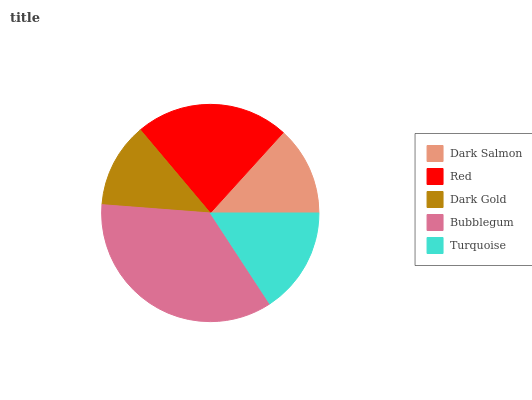Is Dark Gold the minimum?
Answer yes or no. Yes. Is Bubblegum the maximum?
Answer yes or no. Yes. Is Red the minimum?
Answer yes or no. No. Is Red the maximum?
Answer yes or no. No. Is Red greater than Dark Salmon?
Answer yes or no. Yes. Is Dark Salmon less than Red?
Answer yes or no. Yes. Is Dark Salmon greater than Red?
Answer yes or no. No. Is Red less than Dark Salmon?
Answer yes or no. No. Is Turquoise the high median?
Answer yes or no. Yes. Is Turquoise the low median?
Answer yes or no. Yes. Is Dark Salmon the high median?
Answer yes or no. No. Is Bubblegum the low median?
Answer yes or no. No. 